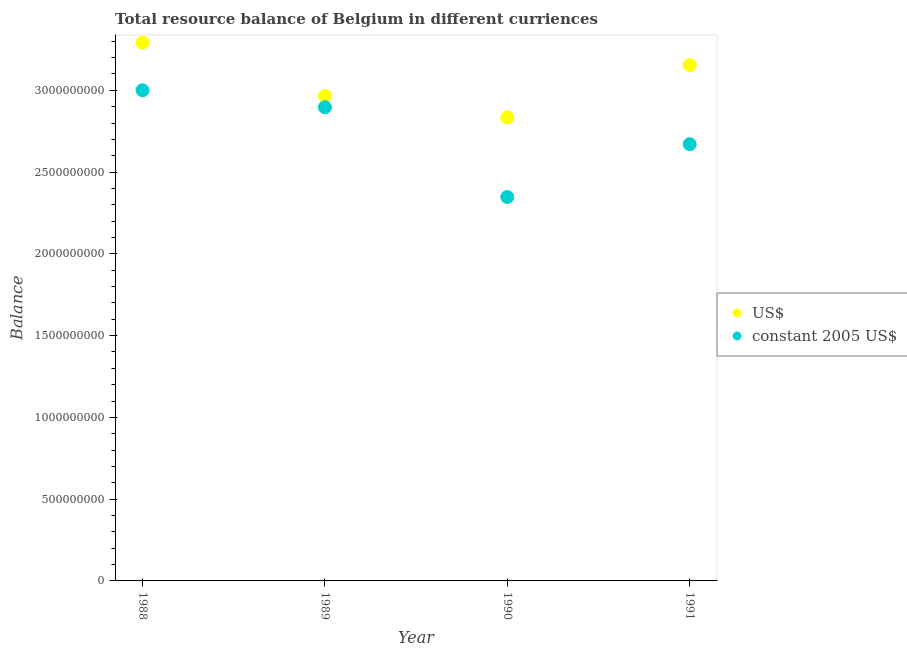What is the resource balance in constant us$ in 1990?
Keep it short and to the point. 2.35e+09. Across all years, what is the maximum resource balance in us$?
Provide a short and direct response. 3.29e+09. Across all years, what is the minimum resource balance in us$?
Keep it short and to the point. 2.83e+09. What is the total resource balance in us$ in the graph?
Make the answer very short. 1.22e+1. What is the difference between the resource balance in us$ in 1989 and that in 1991?
Keep it short and to the point. -1.89e+08. What is the difference between the resource balance in us$ in 1989 and the resource balance in constant us$ in 1988?
Offer a terse response. -3.52e+07. What is the average resource balance in us$ per year?
Offer a very short reply. 3.06e+09. In the year 1989, what is the difference between the resource balance in constant us$ and resource balance in us$?
Your response must be concise. -6.88e+07. In how many years, is the resource balance in constant us$ greater than 2400000000 units?
Make the answer very short. 3. What is the ratio of the resource balance in us$ in 1988 to that in 1989?
Offer a terse response. 1.11. Is the difference between the resource balance in constant us$ in 1988 and 1990 greater than the difference between the resource balance in us$ in 1988 and 1990?
Your answer should be very brief. Yes. What is the difference between the highest and the second highest resource balance in constant us$?
Ensure brevity in your answer.  1.04e+08. What is the difference between the highest and the lowest resource balance in constant us$?
Ensure brevity in your answer.  6.53e+08. In how many years, is the resource balance in us$ greater than the average resource balance in us$ taken over all years?
Your response must be concise. 2. Is the sum of the resource balance in us$ in 1988 and 1989 greater than the maximum resource balance in constant us$ across all years?
Offer a terse response. Yes. Is the resource balance in us$ strictly greater than the resource balance in constant us$ over the years?
Offer a very short reply. Yes. Are the values on the major ticks of Y-axis written in scientific E-notation?
Provide a succinct answer. No. Does the graph contain grids?
Provide a short and direct response. No. How are the legend labels stacked?
Make the answer very short. Vertical. What is the title of the graph?
Give a very brief answer. Total resource balance of Belgium in different curriences. What is the label or title of the X-axis?
Offer a very short reply. Year. What is the label or title of the Y-axis?
Make the answer very short. Balance. What is the Balance of US$ in 1988?
Keep it short and to the point. 3.29e+09. What is the Balance of constant 2005 US$ in 1988?
Offer a terse response. 3.00e+09. What is the Balance in US$ in 1989?
Provide a short and direct response. 2.97e+09. What is the Balance in constant 2005 US$ in 1989?
Provide a succinct answer. 2.90e+09. What is the Balance of US$ in 1990?
Your answer should be very brief. 2.83e+09. What is the Balance of constant 2005 US$ in 1990?
Offer a very short reply. 2.35e+09. What is the Balance in US$ in 1991?
Make the answer very short. 3.15e+09. What is the Balance in constant 2005 US$ in 1991?
Your answer should be very brief. 2.67e+09. Across all years, what is the maximum Balance in US$?
Your response must be concise. 3.29e+09. Across all years, what is the maximum Balance of constant 2005 US$?
Ensure brevity in your answer.  3.00e+09. Across all years, what is the minimum Balance of US$?
Keep it short and to the point. 2.83e+09. Across all years, what is the minimum Balance in constant 2005 US$?
Offer a terse response. 2.35e+09. What is the total Balance in US$ in the graph?
Your answer should be very brief. 1.22e+1. What is the total Balance in constant 2005 US$ in the graph?
Ensure brevity in your answer.  1.09e+1. What is the difference between the Balance in US$ in 1988 and that in 1989?
Give a very brief answer. 3.27e+08. What is the difference between the Balance in constant 2005 US$ in 1988 and that in 1989?
Your response must be concise. 1.04e+08. What is the difference between the Balance in US$ in 1988 and that in 1990?
Make the answer very short. 4.58e+08. What is the difference between the Balance in constant 2005 US$ in 1988 and that in 1990?
Give a very brief answer. 6.53e+08. What is the difference between the Balance of US$ in 1988 and that in 1991?
Keep it short and to the point. 1.37e+08. What is the difference between the Balance in constant 2005 US$ in 1988 and that in 1991?
Provide a succinct answer. 3.30e+08. What is the difference between the Balance in US$ in 1989 and that in 1990?
Your answer should be very brief. 1.31e+08. What is the difference between the Balance in constant 2005 US$ in 1989 and that in 1990?
Make the answer very short. 5.49e+08. What is the difference between the Balance in US$ in 1989 and that in 1991?
Provide a short and direct response. -1.89e+08. What is the difference between the Balance in constant 2005 US$ in 1989 and that in 1991?
Your answer should be compact. 2.26e+08. What is the difference between the Balance of US$ in 1990 and that in 1991?
Your response must be concise. -3.21e+08. What is the difference between the Balance of constant 2005 US$ in 1990 and that in 1991?
Keep it short and to the point. -3.23e+08. What is the difference between the Balance of US$ in 1988 and the Balance of constant 2005 US$ in 1989?
Provide a succinct answer. 3.95e+08. What is the difference between the Balance in US$ in 1988 and the Balance in constant 2005 US$ in 1990?
Your response must be concise. 9.44e+08. What is the difference between the Balance of US$ in 1988 and the Balance of constant 2005 US$ in 1991?
Offer a very short reply. 6.21e+08. What is the difference between the Balance of US$ in 1989 and the Balance of constant 2005 US$ in 1990?
Your answer should be compact. 6.18e+08. What is the difference between the Balance in US$ in 1989 and the Balance in constant 2005 US$ in 1991?
Ensure brevity in your answer.  2.95e+08. What is the difference between the Balance of US$ in 1990 and the Balance of constant 2005 US$ in 1991?
Your response must be concise. 1.64e+08. What is the average Balance in US$ per year?
Your answer should be very brief. 3.06e+09. What is the average Balance of constant 2005 US$ per year?
Ensure brevity in your answer.  2.73e+09. In the year 1988, what is the difference between the Balance in US$ and Balance in constant 2005 US$?
Your answer should be compact. 2.91e+08. In the year 1989, what is the difference between the Balance in US$ and Balance in constant 2005 US$?
Your response must be concise. 6.88e+07. In the year 1990, what is the difference between the Balance in US$ and Balance in constant 2005 US$?
Offer a very short reply. 4.86e+08. In the year 1991, what is the difference between the Balance of US$ and Balance of constant 2005 US$?
Ensure brevity in your answer.  4.84e+08. What is the ratio of the Balance of US$ in 1988 to that in 1989?
Offer a terse response. 1.11. What is the ratio of the Balance of constant 2005 US$ in 1988 to that in 1989?
Give a very brief answer. 1.04. What is the ratio of the Balance in US$ in 1988 to that in 1990?
Give a very brief answer. 1.16. What is the ratio of the Balance of constant 2005 US$ in 1988 to that in 1990?
Give a very brief answer. 1.28. What is the ratio of the Balance in US$ in 1988 to that in 1991?
Give a very brief answer. 1.04. What is the ratio of the Balance of constant 2005 US$ in 1988 to that in 1991?
Offer a terse response. 1.12. What is the ratio of the Balance in US$ in 1989 to that in 1990?
Make the answer very short. 1.05. What is the ratio of the Balance in constant 2005 US$ in 1989 to that in 1990?
Keep it short and to the point. 1.23. What is the ratio of the Balance in US$ in 1989 to that in 1991?
Give a very brief answer. 0.94. What is the ratio of the Balance in constant 2005 US$ in 1989 to that in 1991?
Provide a short and direct response. 1.08. What is the ratio of the Balance of US$ in 1990 to that in 1991?
Provide a short and direct response. 0.9. What is the ratio of the Balance of constant 2005 US$ in 1990 to that in 1991?
Provide a succinct answer. 0.88. What is the difference between the highest and the second highest Balance of US$?
Provide a short and direct response. 1.37e+08. What is the difference between the highest and the second highest Balance of constant 2005 US$?
Provide a succinct answer. 1.04e+08. What is the difference between the highest and the lowest Balance of US$?
Your answer should be compact. 4.58e+08. What is the difference between the highest and the lowest Balance of constant 2005 US$?
Give a very brief answer. 6.53e+08. 